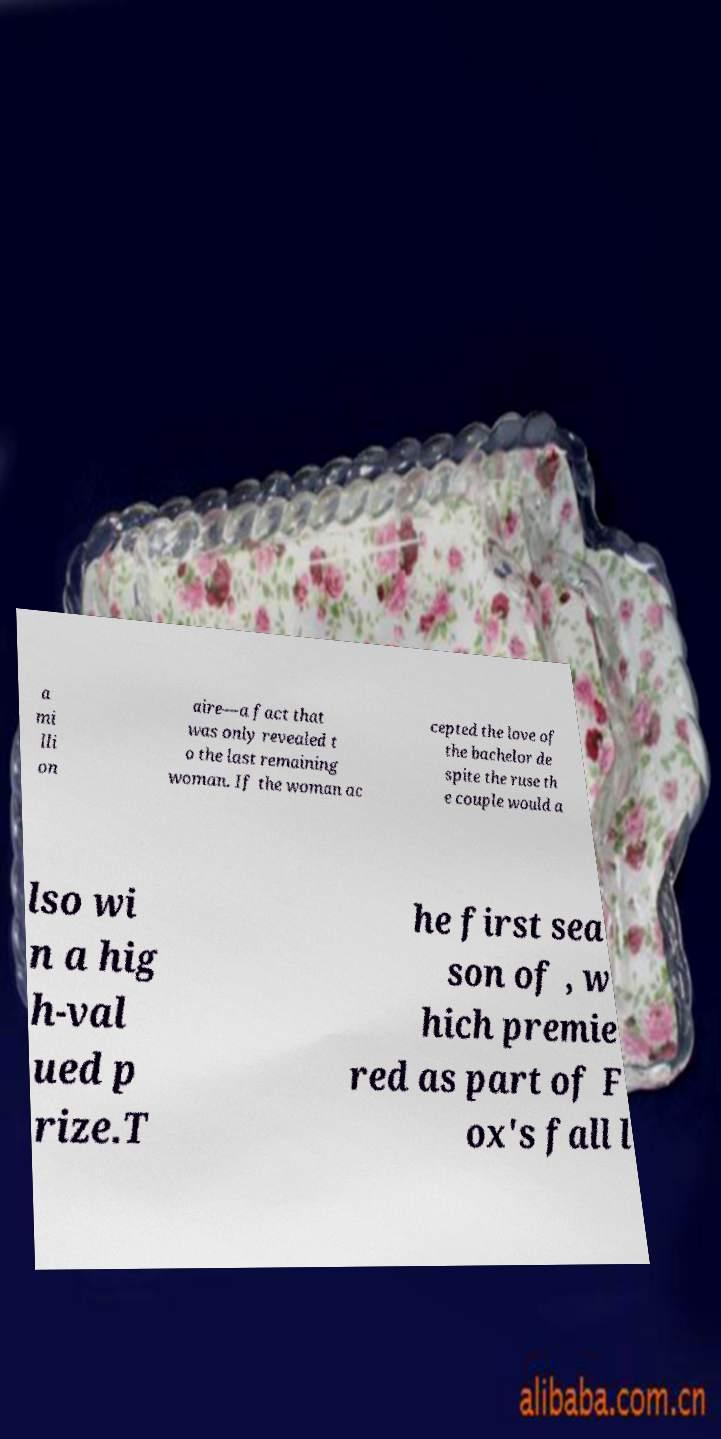Please identify and transcribe the text found in this image. a mi lli on aire—a fact that was only revealed t o the last remaining woman. If the woman ac cepted the love of the bachelor de spite the ruse th e couple would a lso wi n a hig h-val ued p rize.T he first sea son of , w hich premie red as part of F ox's fall l 